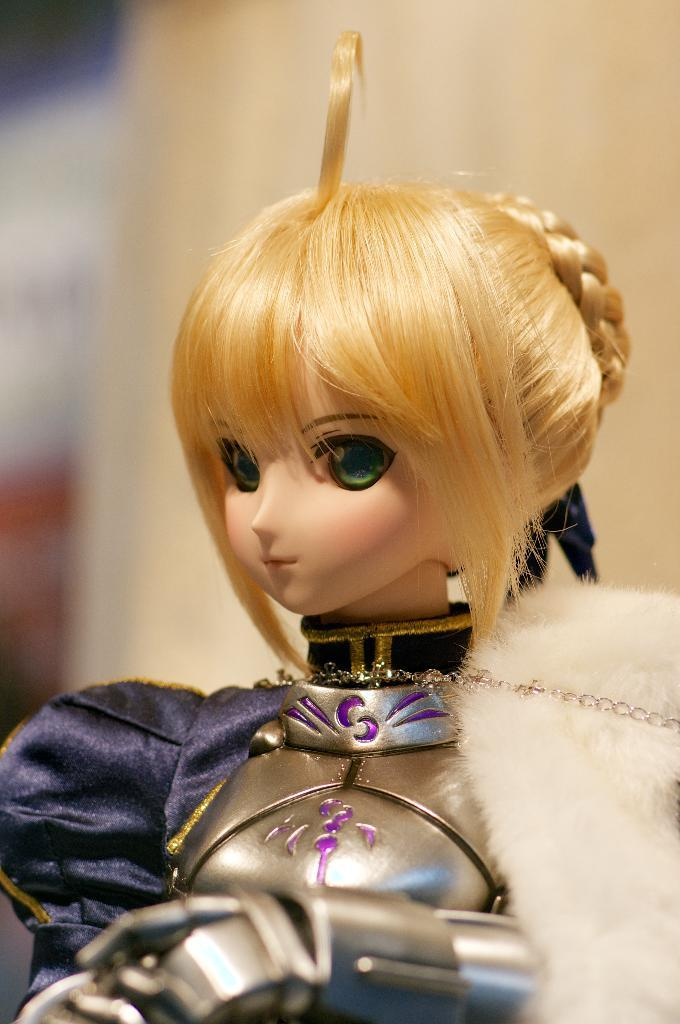What is the main subject of the image? There is a doll in the image. Can you describe the doll in the image? The doll is of a girl. Does the doll in the image have the ability to exist outside of the image? The question of the doll's existence outside of the image is not relevant, as the image only shows a representation of the doll. 